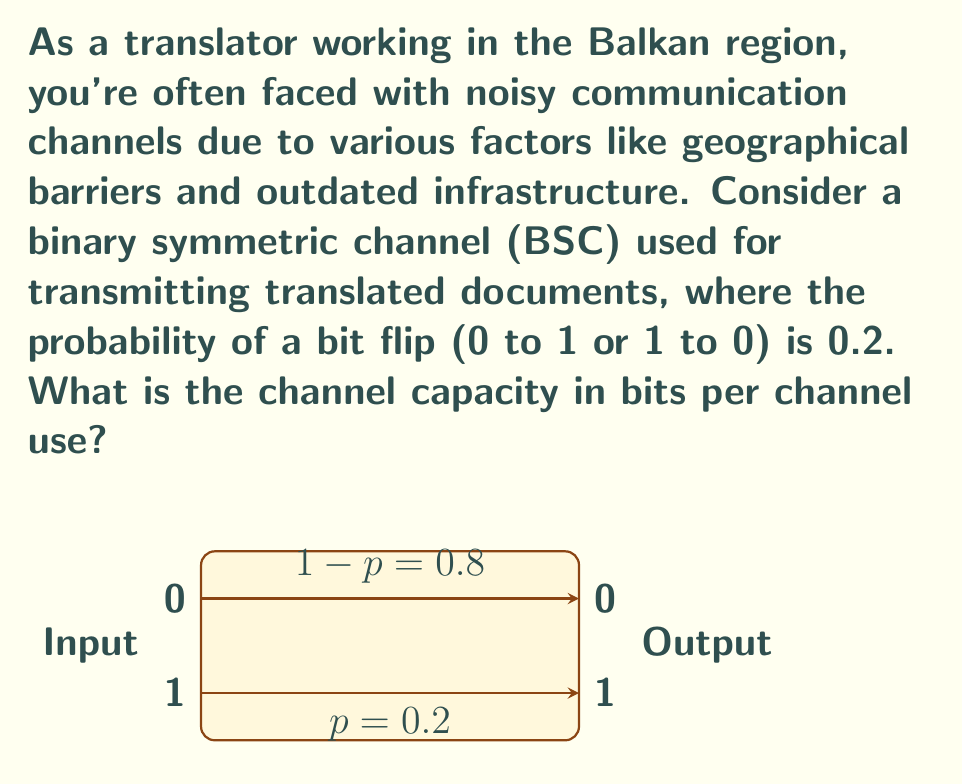Can you answer this question? To determine the channel capacity for this binary symmetric channel (BSC), we'll follow these steps:

1) The channel capacity (C) for a BSC is given by the formula:

   $$C = 1 - H(p)$$

   where $H(p)$ is the binary entropy function and $p$ is the probability of a bit flip.

2) The binary entropy function is defined as:

   $$H(p) = -p\log_2(p) - (1-p)\log_2(1-p)$$

3) We're given that $p = 0.2$. Let's calculate $H(0.2)$:

   $$\begin{align}
   H(0.2) &= -0.2\log_2(0.2) - 0.8\log_2(0.8) \\
   &\approx -0.2(-2.322) - 0.8(-0.322) \\
   &\approx 0.4644 + 0.2576 \\
   &\approx 0.7220
   \end{align}$$

4) Now we can calculate the channel capacity:

   $$\begin{align}
   C &= 1 - H(0.2) \\
   &= 1 - 0.7220 \\
   &\approx 0.2780
   \end{align}$$

5) Therefore, the channel capacity is approximately 0.2780 bits per channel use.

This means that for each use of the channel, you can reliably transmit about 0.2780 bits of information, despite the noise in the channel.
Answer: 0.2780 bits per channel use 